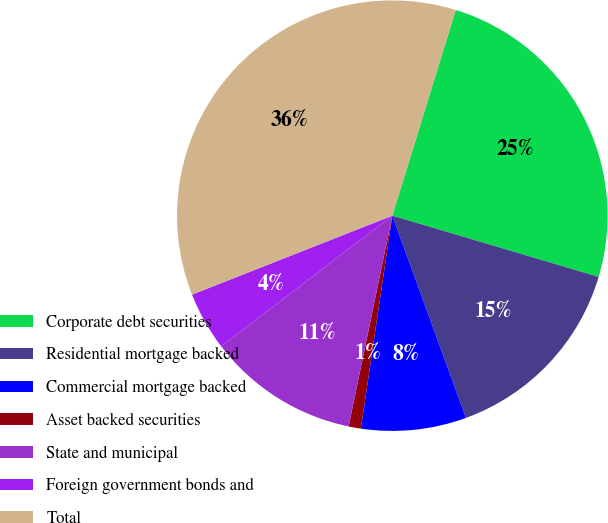Convert chart to OTSL. <chart><loc_0><loc_0><loc_500><loc_500><pie_chart><fcel>Corporate debt securities<fcel>Residential mortgage backed<fcel>Commercial mortgage backed<fcel>Asset backed securities<fcel>State and municipal<fcel>Foreign government bonds and<fcel>Total<nl><fcel>24.83%<fcel>14.85%<fcel>7.89%<fcel>0.92%<fcel>11.37%<fcel>4.4%<fcel>35.74%<nl></chart> 